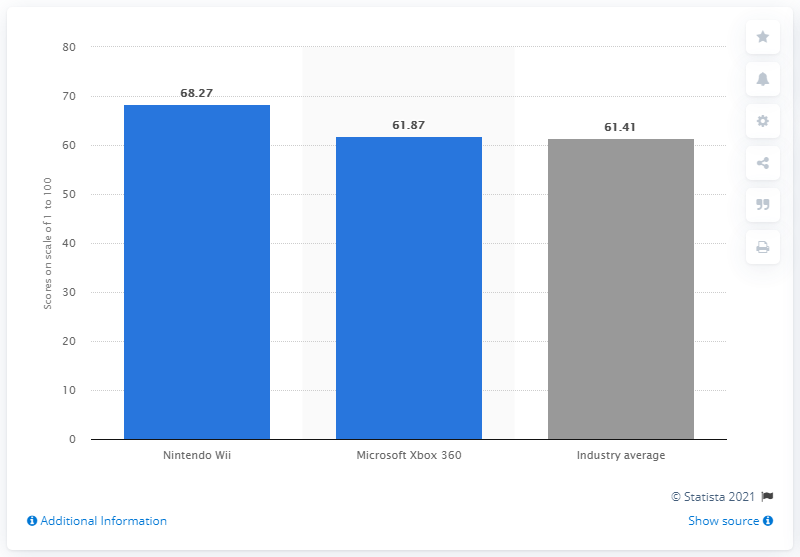How does the industry average equity score compare with the individual scores of Nintendo Wii and Microsoft Xbox 360? The industry average equity score in 2012 was 61.41, which is notably lower than Nintendo Wii's score of 68.27 and slightly lower than Microsoft Xbox 360's score of 61.87. This comparison highlights Nintendo Wii's superior performance relative to the overall industry and its key competitor. 